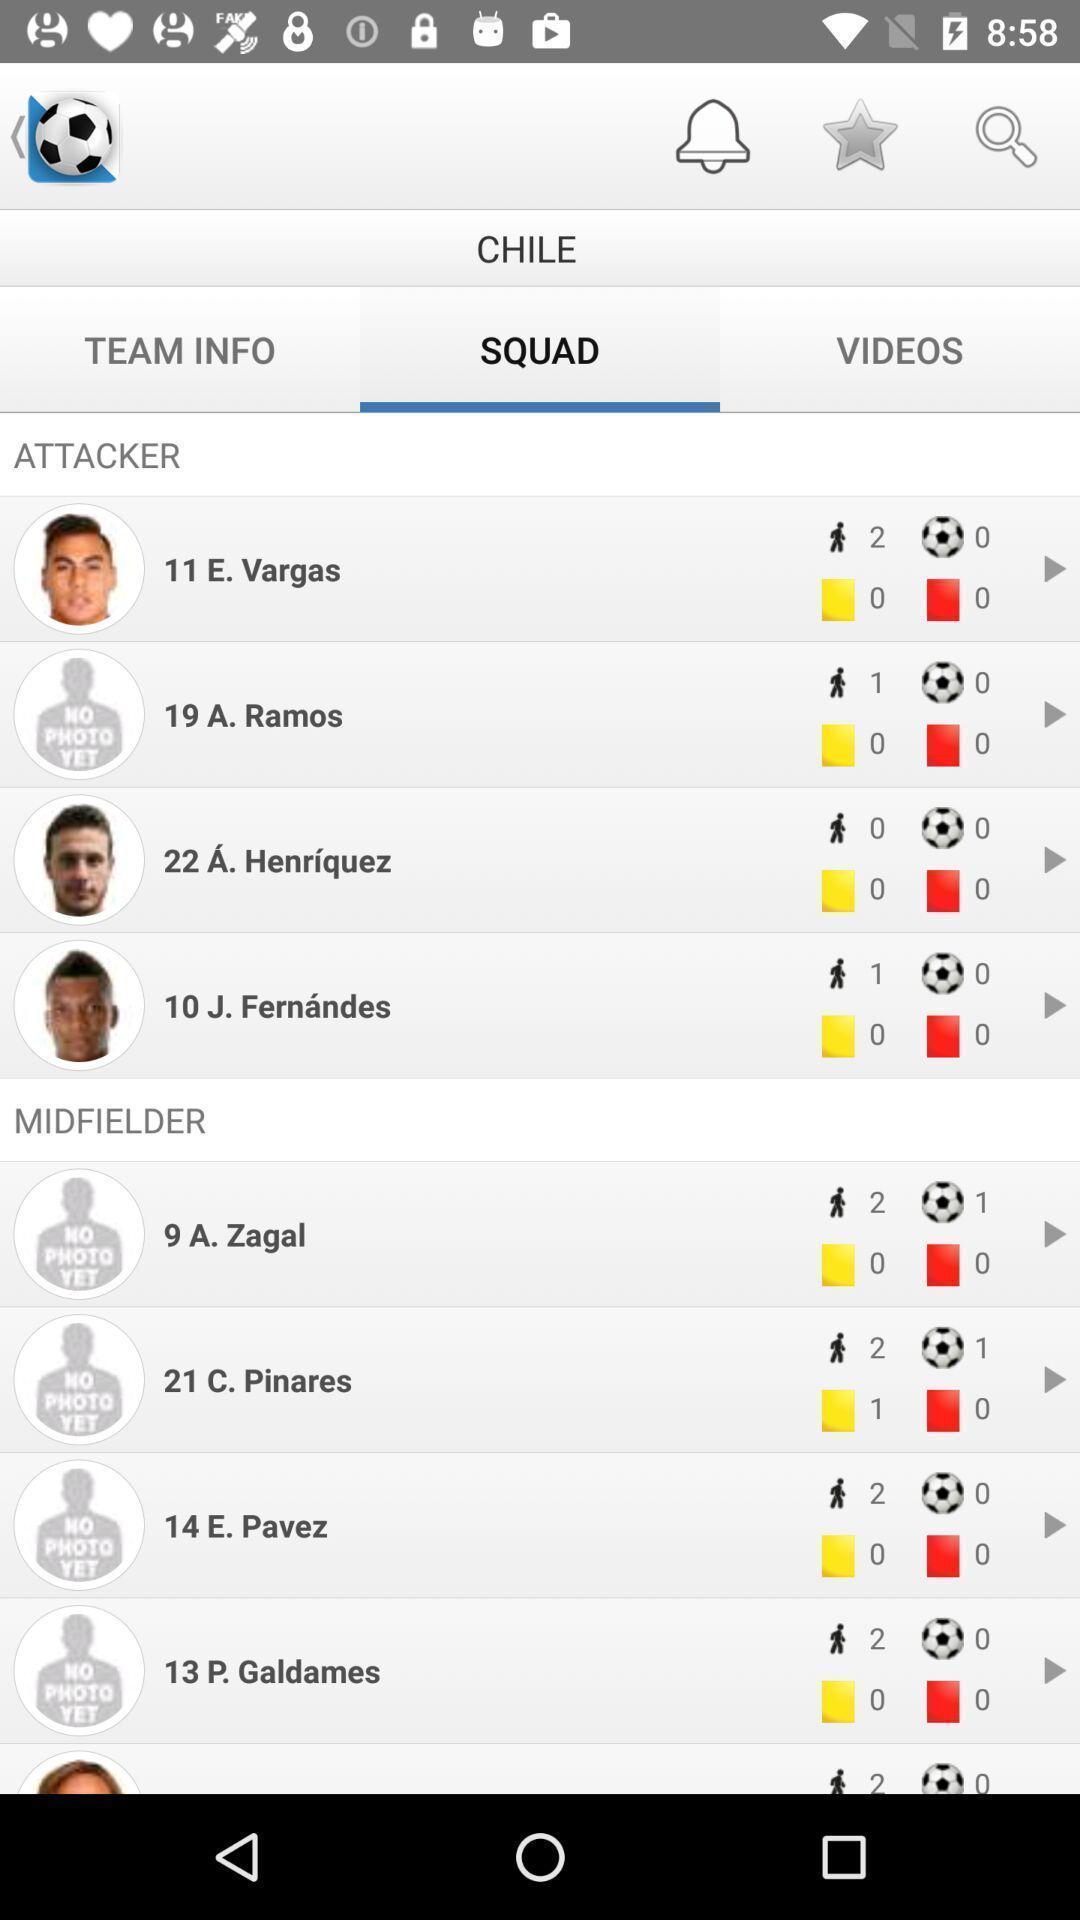Describe the key features of this screenshot. Squad score page in a sport app. 